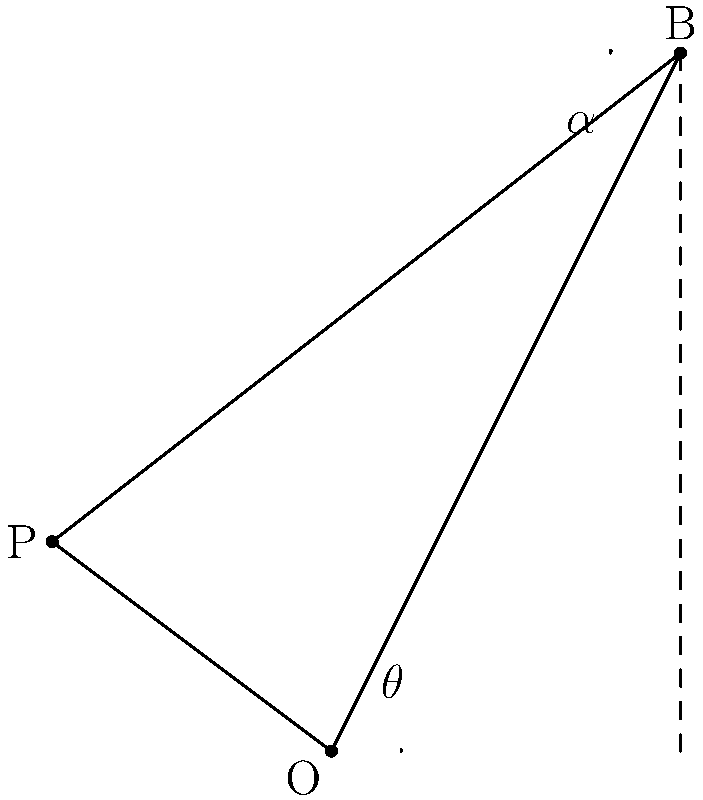As a former Oregon State basketball player, you're practicing bank shots. You're standing at point P, aiming to hit the backboard at point B and have the ball go through the hoop at point O. Given that the angle between the backboard and the floor is 90°, and the angle $\theta$ between the floor and the line from the hoop to the backboard is 30°, what should be the angle $\alpha$ of your bank shot off the backboard? To solve this problem, we'll use the law of reflection, which states that the angle of incidence equals the angle of reflection.

1) First, we need to find the angle of the incoming shot (PB) relative to the perpendicular line to the backboard.

2) The perpendicular line to the backboard makes a 90° angle with the floor. The line OB makes a 30° angle with the floor. So, the angle between OB and the perpendicular is 60°.

3) Let's call the angle between PB and OB as $\beta$. We can see that:
   $\alpha + \beta = 60°$

4) According to the law of reflection, the angle of incidence (which is $\alpha$) should equal the angle of reflection (which is 60° - $\alpha$).

5) We can write this as an equation:
   $\alpha = 60° - \alpha$

6) Solving this equation:
   $2\alpha = 60°$
   $\alpha = 30°$

Therefore, the angle of the bank shot off the backboard should be 30°.
Answer: $30°$ 